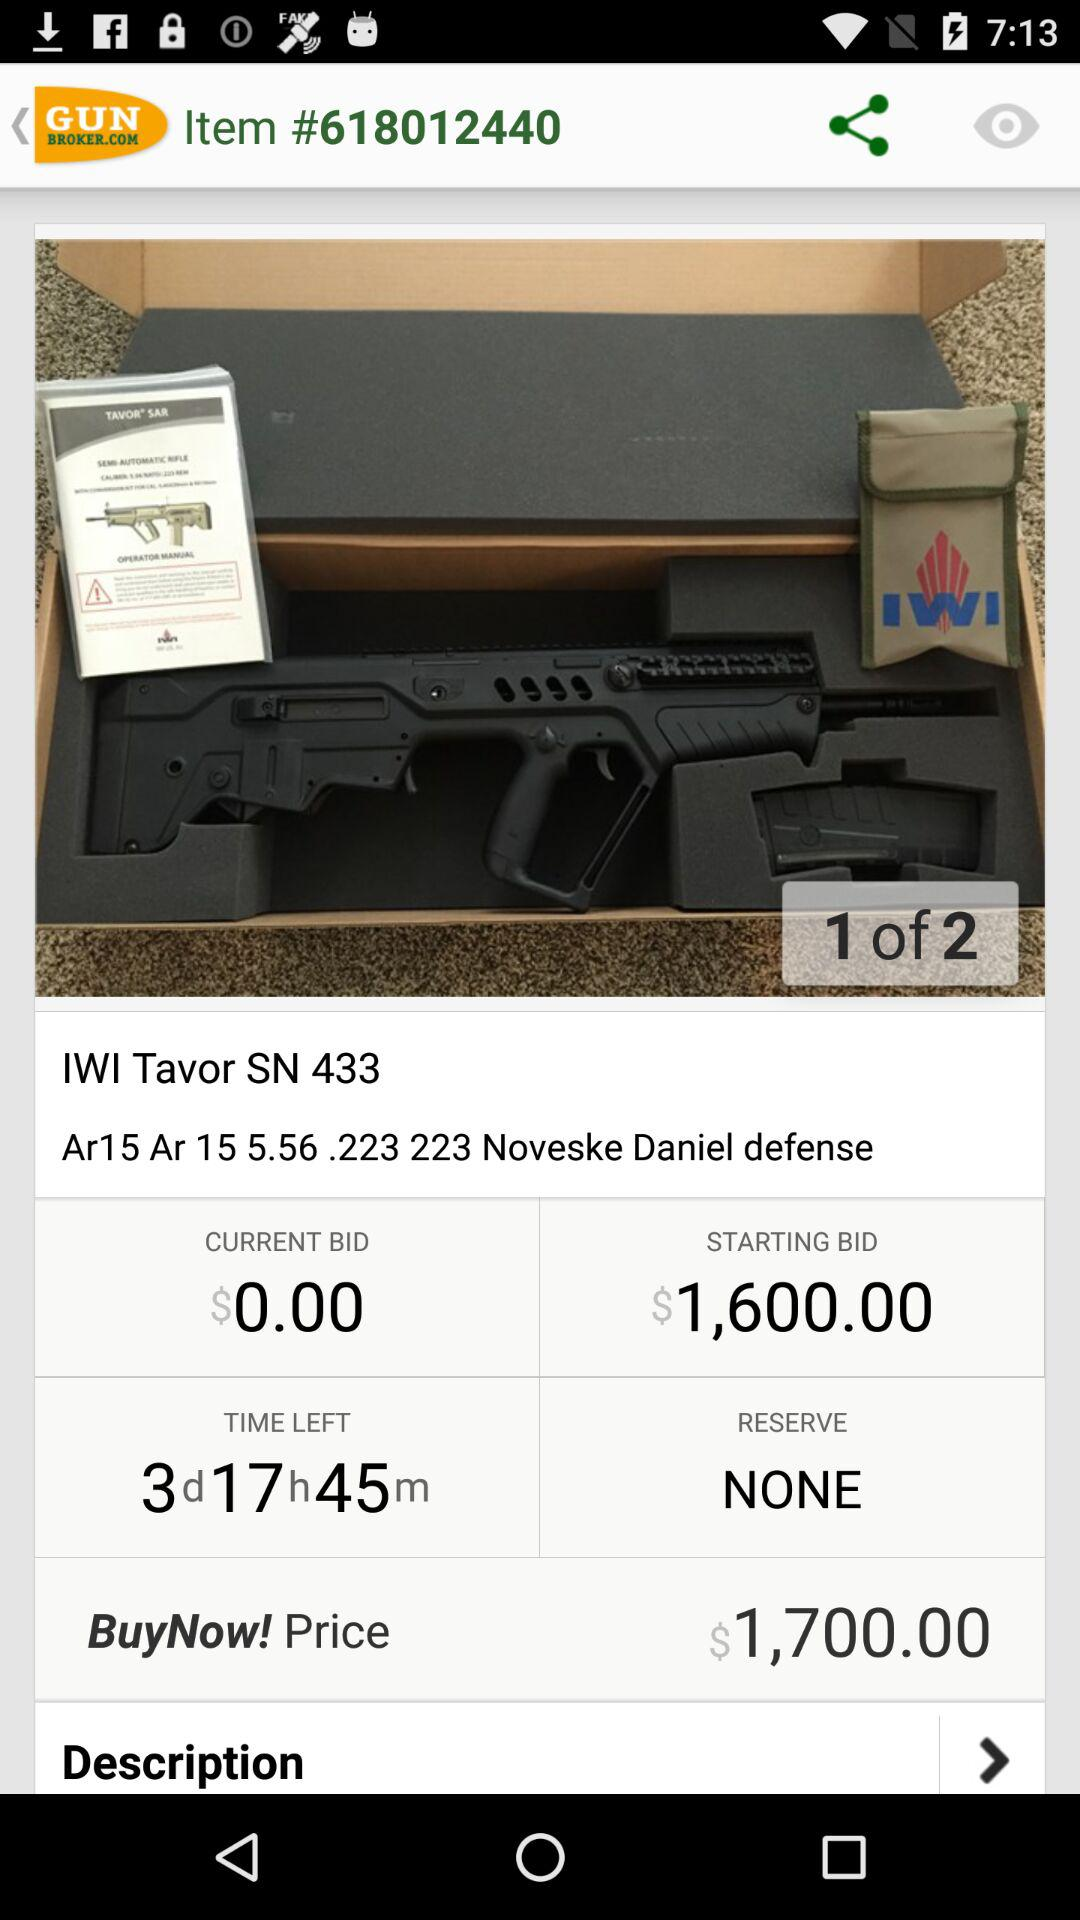How much time is left on this auction?
Answer the question using a single word or phrase. 3d17h45m 